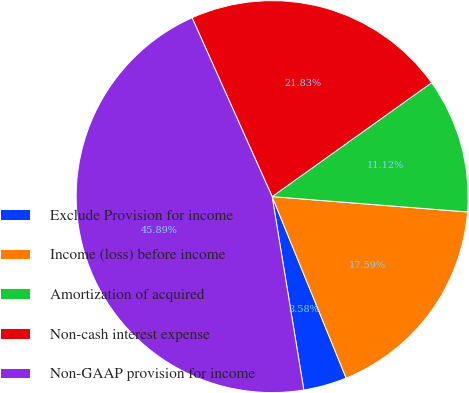Convert chart to OTSL. <chart><loc_0><loc_0><loc_500><loc_500><pie_chart><fcel>Exclude Provision for income<fcel>Income (loss) before income<fcel>Amortization of acquired<fcel>Non-cash interest expense<fcel>Non-GAAP provision for income<nl><fcel>3.58%<fcel>17.59%<fcel>11.12%<fcel>21.83%<fcel>45.89%<nl></chart> 